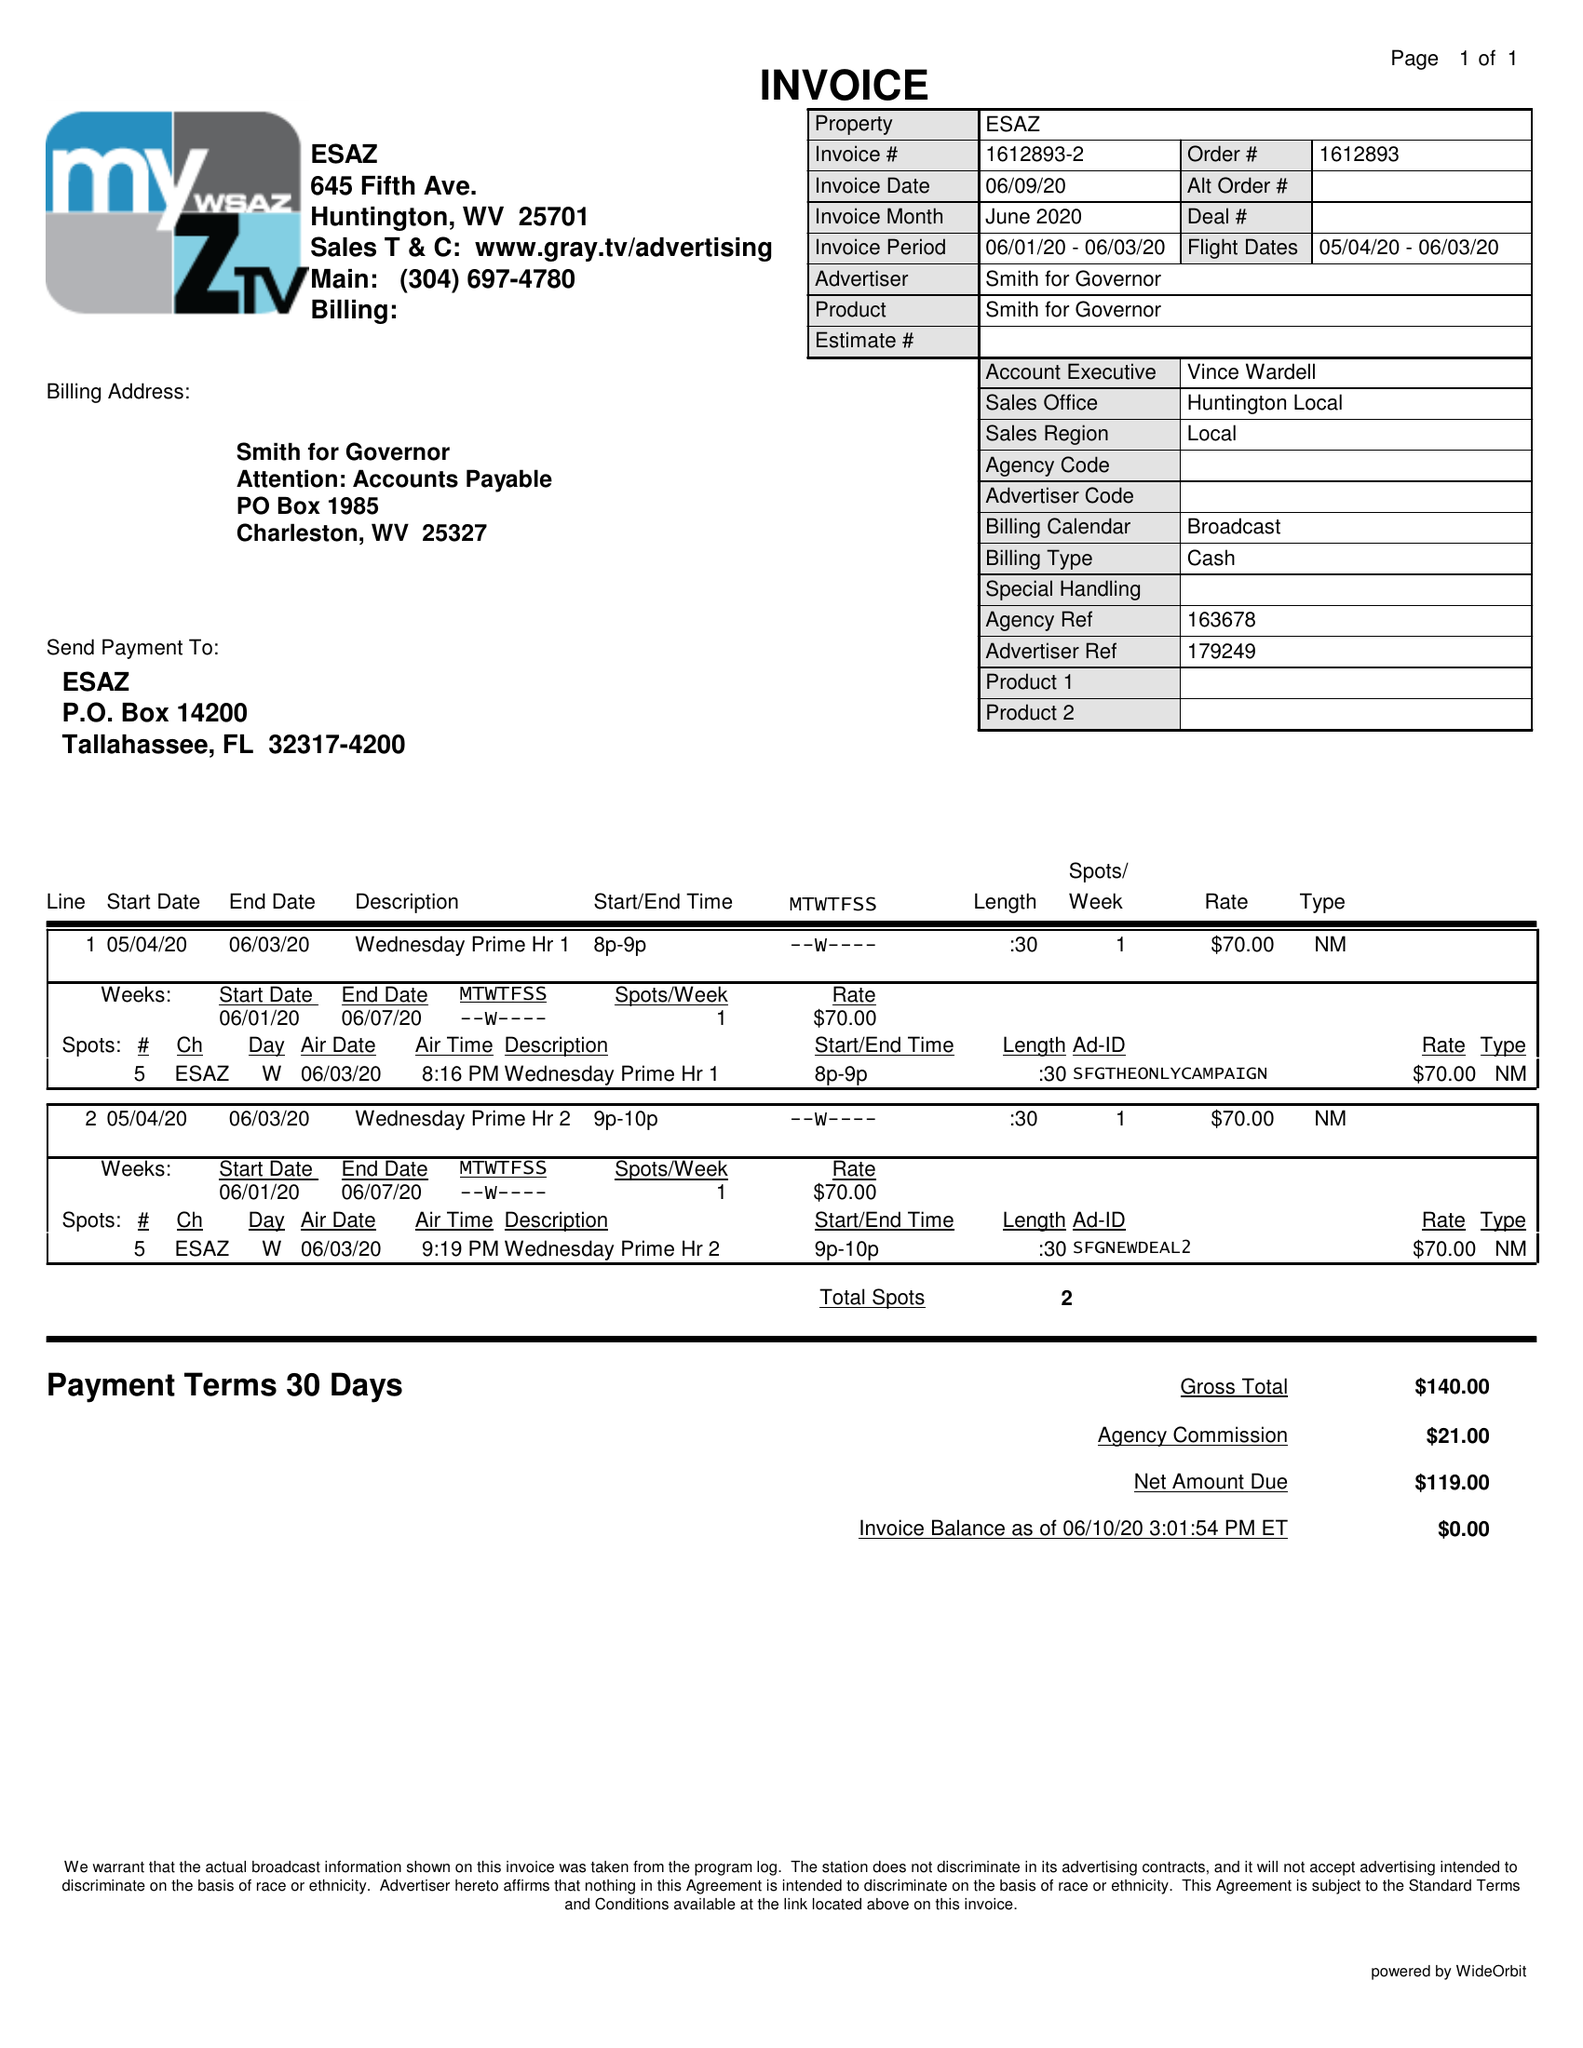What is the value for the gross_amount?
Answer the question using a single word or phrase. 140.00 